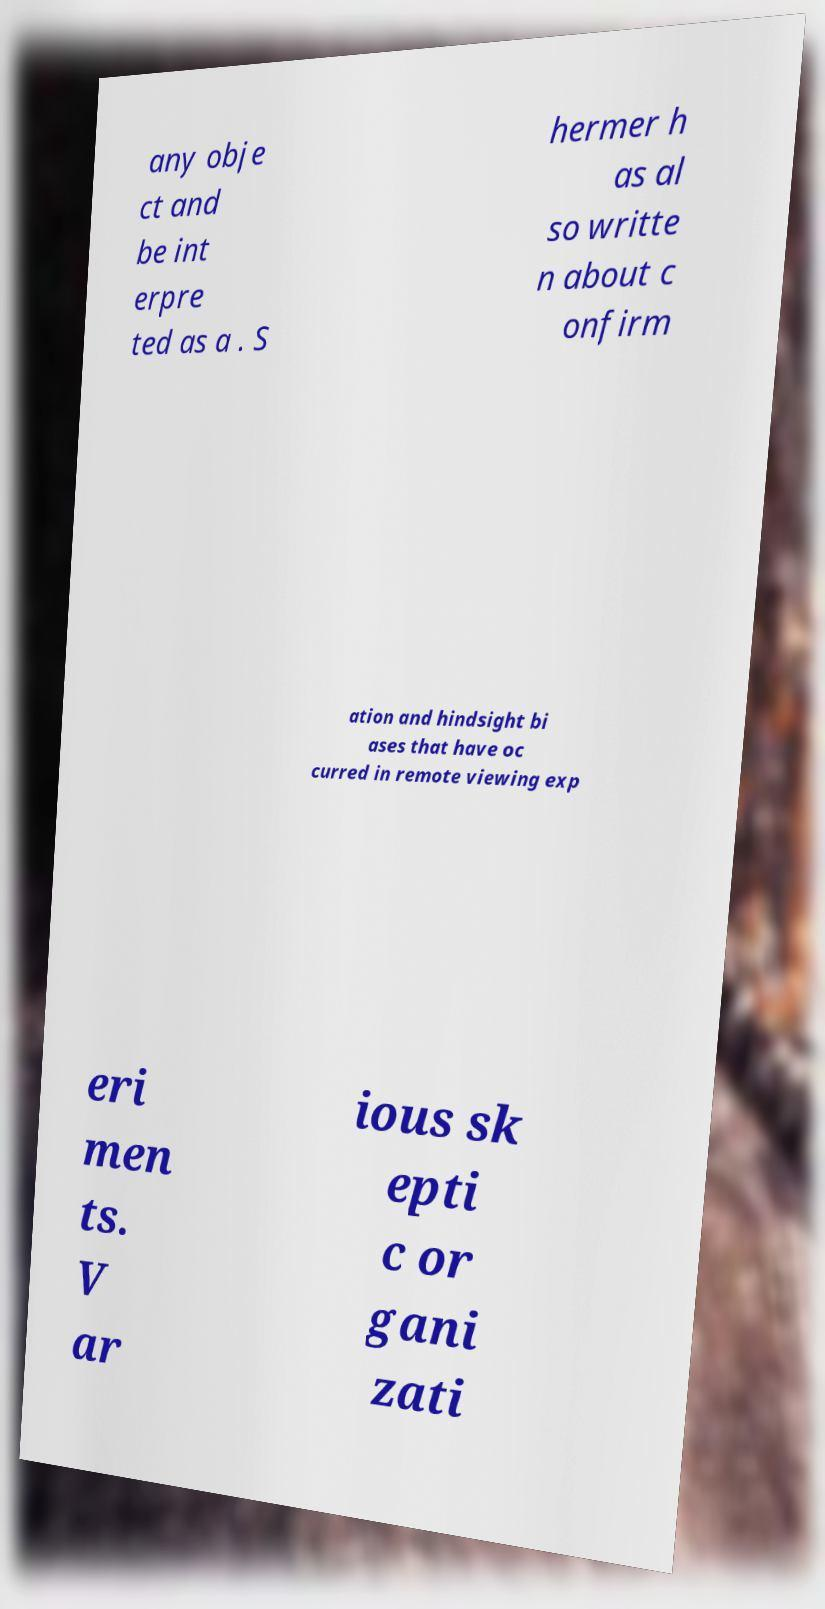There's text embedded in this image that I need extracted. Can you transcribe it verbatim? any obje ct and be int erpre ted as a . S hermer h as al so writte n about c onfirm ation and hindsight bi ases that have oc curred in remote viewing exp eri men ts. V ar ious sk epti c or gani zati 